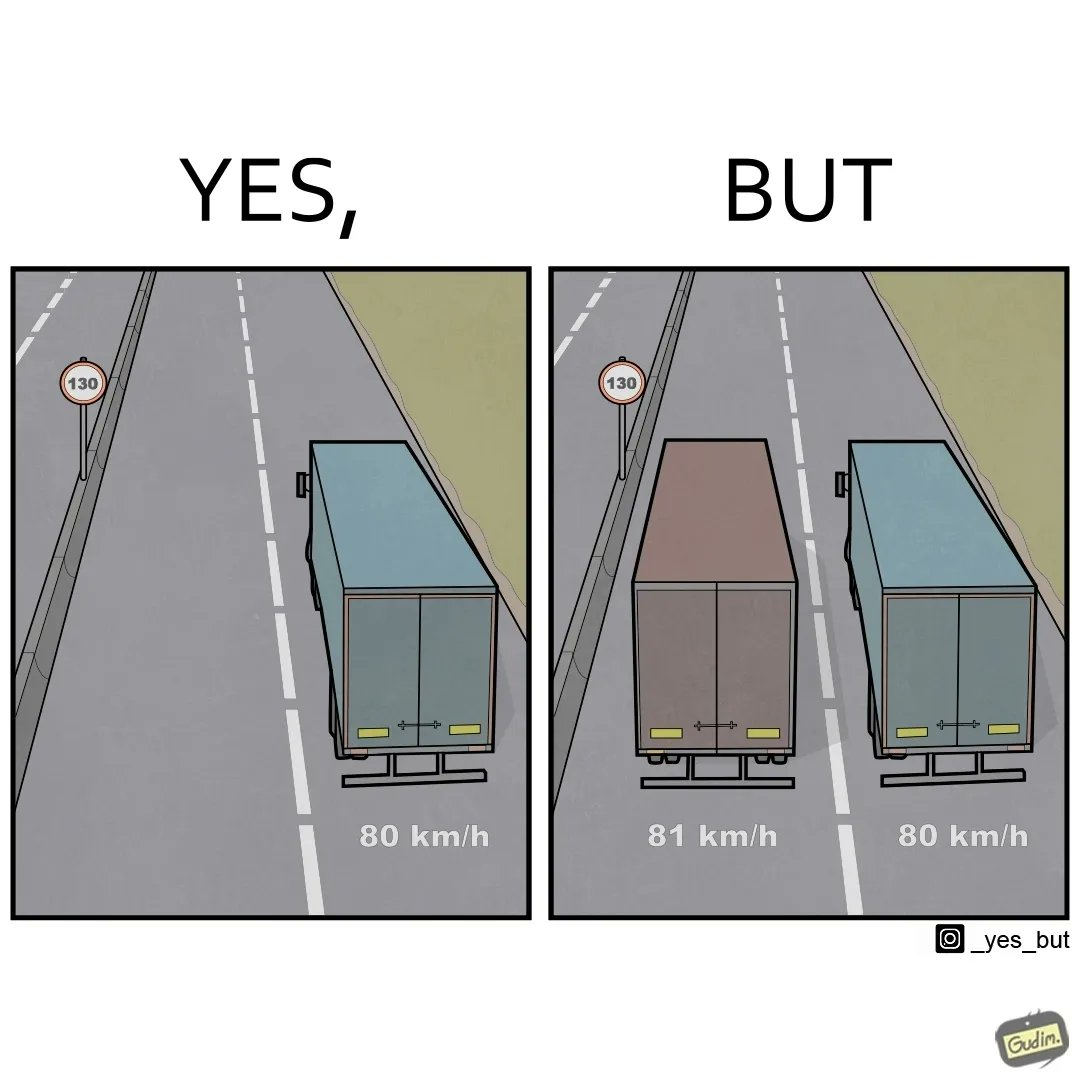Describe what you see in the left and right parts of this image. In the left part of the image: It is a truck travelling at 80km/h in a 130km/h zone In the right part of the image: They are two trucks travelling at 80km/h and 81km/h respectively in a 130km/h zone 